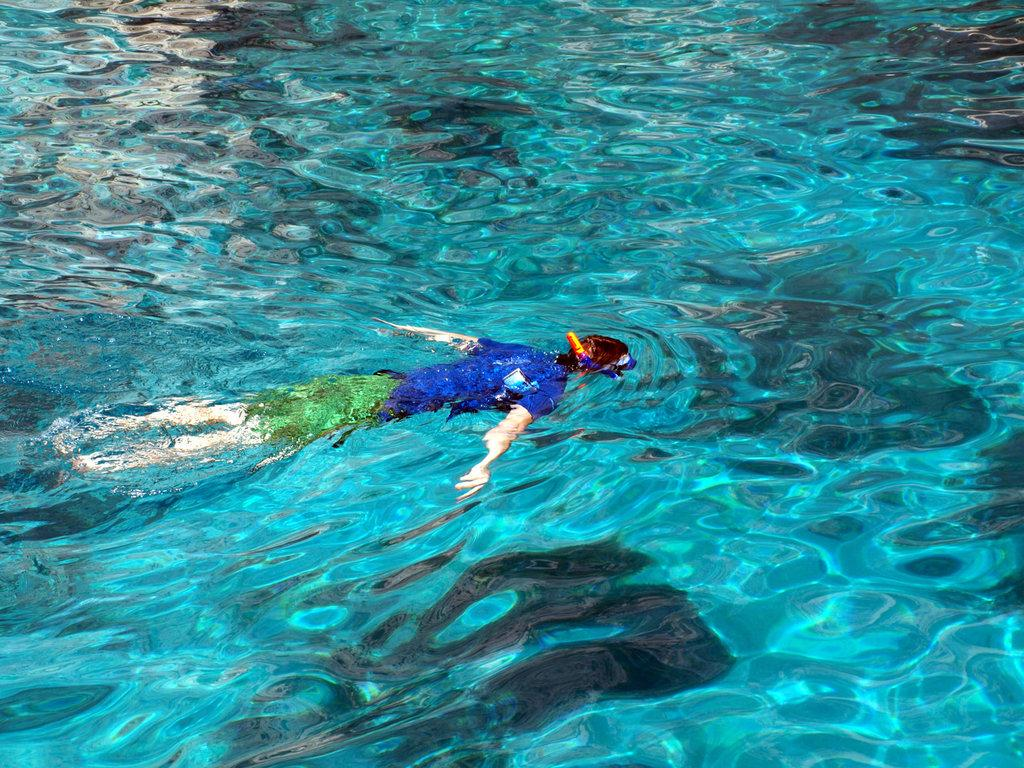What is the main activity being performed in the image? There is a human swimming in the water in the image. Can you describe the environment in which the activity is taking place? The activity is taking place in water. What is the story behind the owner of the water in the image? There is no story or owner mentioned in the image, as it only shows a human swimming in water. 